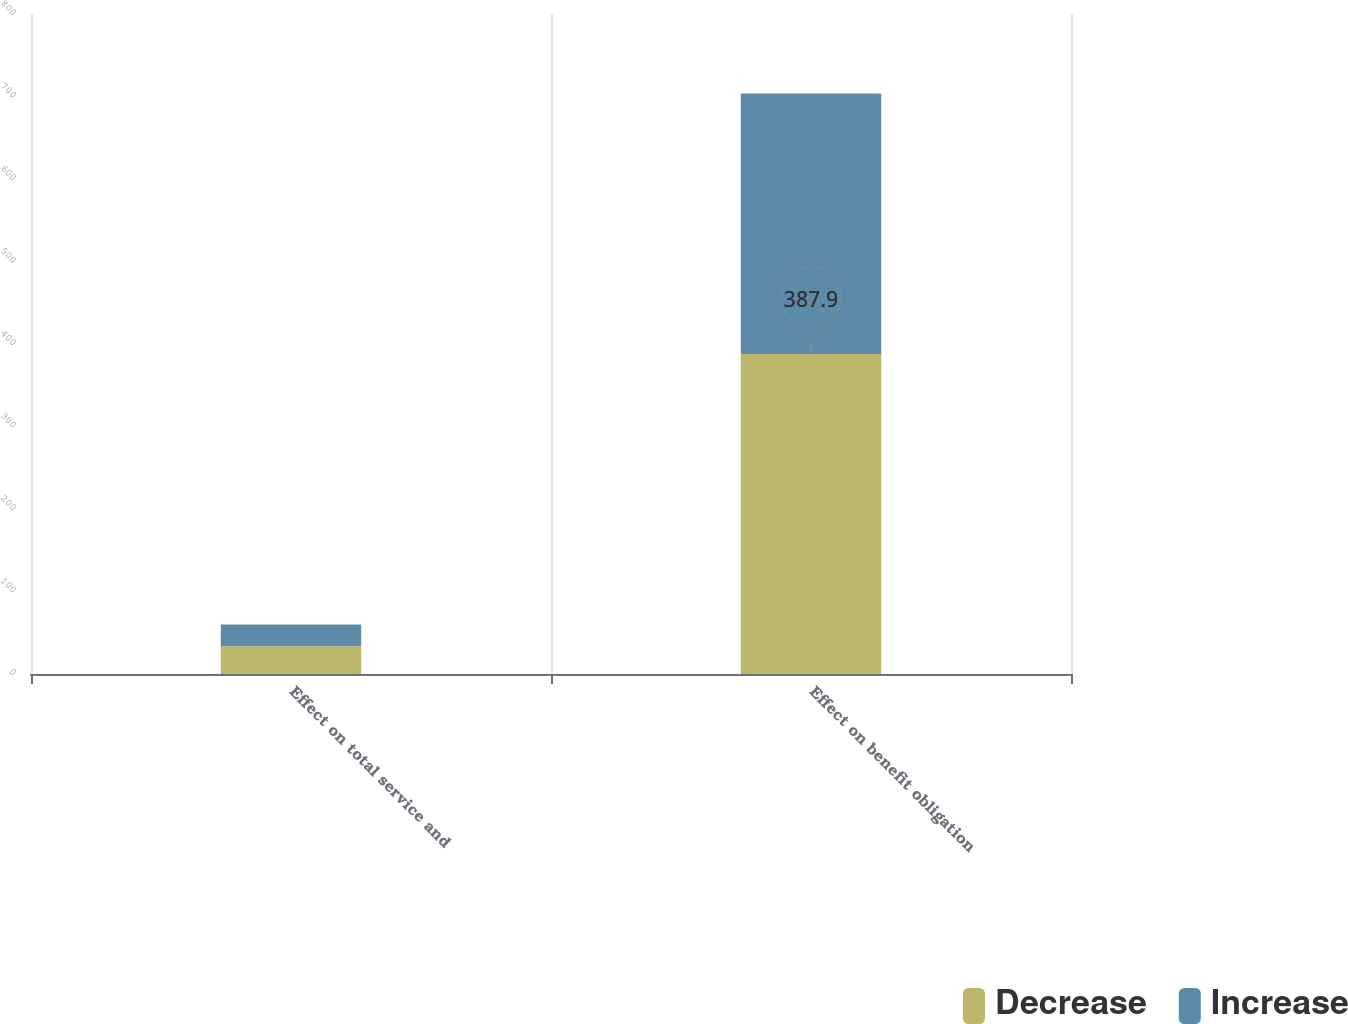Convert chart. <chart><loc_0><loc_0><loc_500><loc_500><stacked_bar_chart><ecel><fcel>Effect on total service and<fcel>Effect on benefit obligation<nl><fcel>Decrease<fcel>33.5<fcel>387.9<nl><fcel>Increase<fcel>26.5<fcel>315.8<nl></chart> 